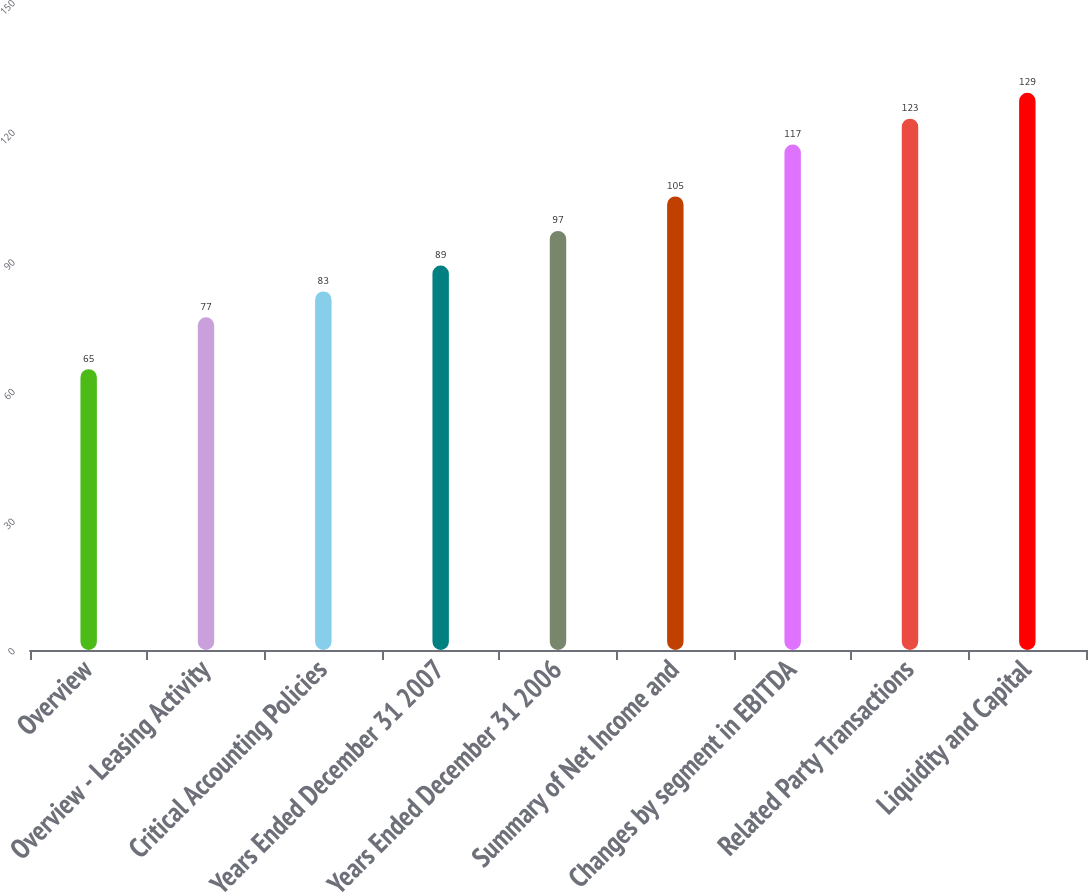Convert chart. <chart><loc_0><loc_0><loc_500><loc_500><bar_chart><fcel>Overview<fcel>Overview - Leasing Activity<fcel>Critical Accounting Policies<fcel>Years Ended December 31 2007<fcel>Years Ended December 31 2006<fcel>Summary of Net Income and<fcel>Changes by segment in EBITDA<fcel>Related Party Transactions<fcel>Liquidity and Capital<nl><fcel>65<fcel>77<fcel>83<fcel>89<fcel>97<fcel>105<fcel>117<fcel>123<fcel>129<nl></chart> 